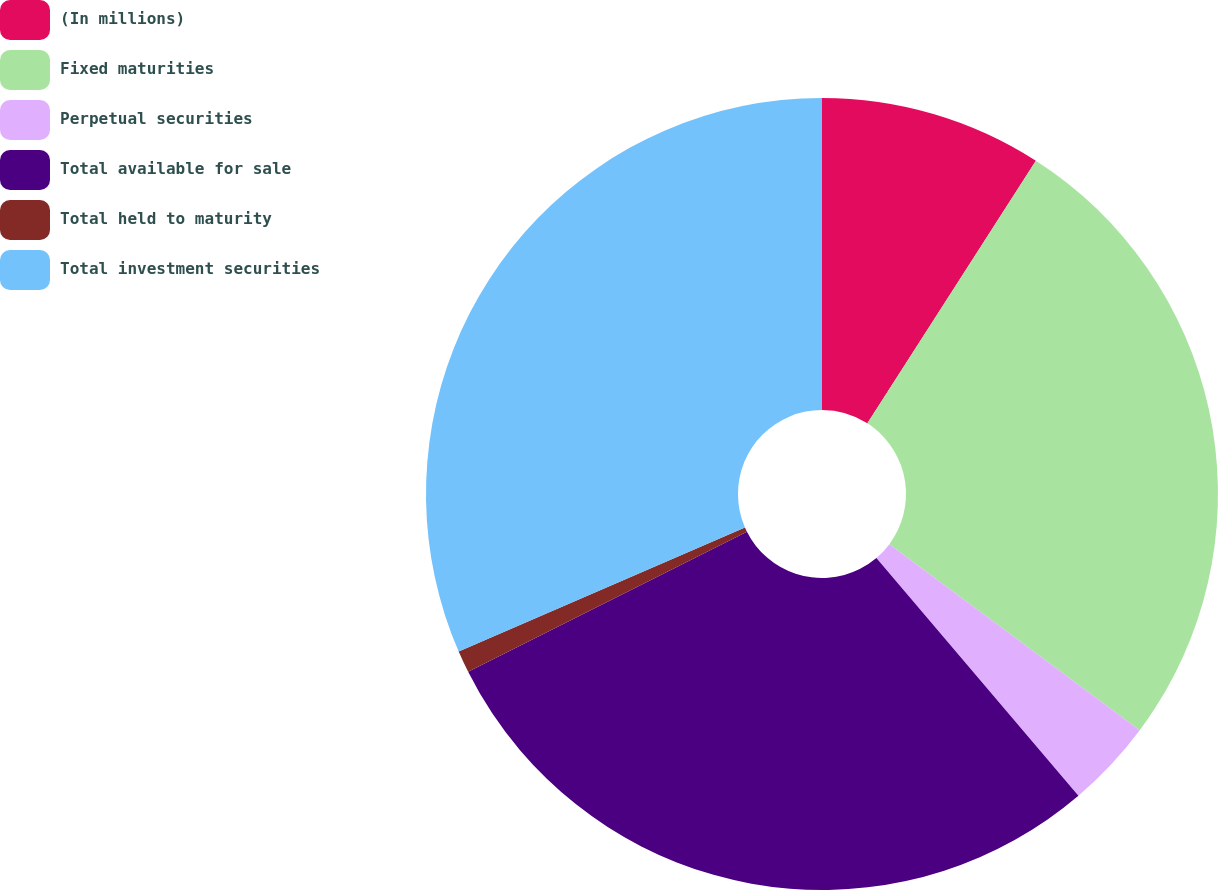Convert chart. <chart><loc_0><loc_0><loc_500><loc_500><pie_chart><fcel>(In millions)<fcel>Fixed maturities<fcel>Perpetual securities<fcel>Total available for sale<fcel>Total held to maturity<fcel>Total investment securities<nl><fcel>9.08%<fcel>26.1%<fcel>3.61%<fcel>28.8%<fcel>0.9%<fcel>31.51%<nl></chart> 